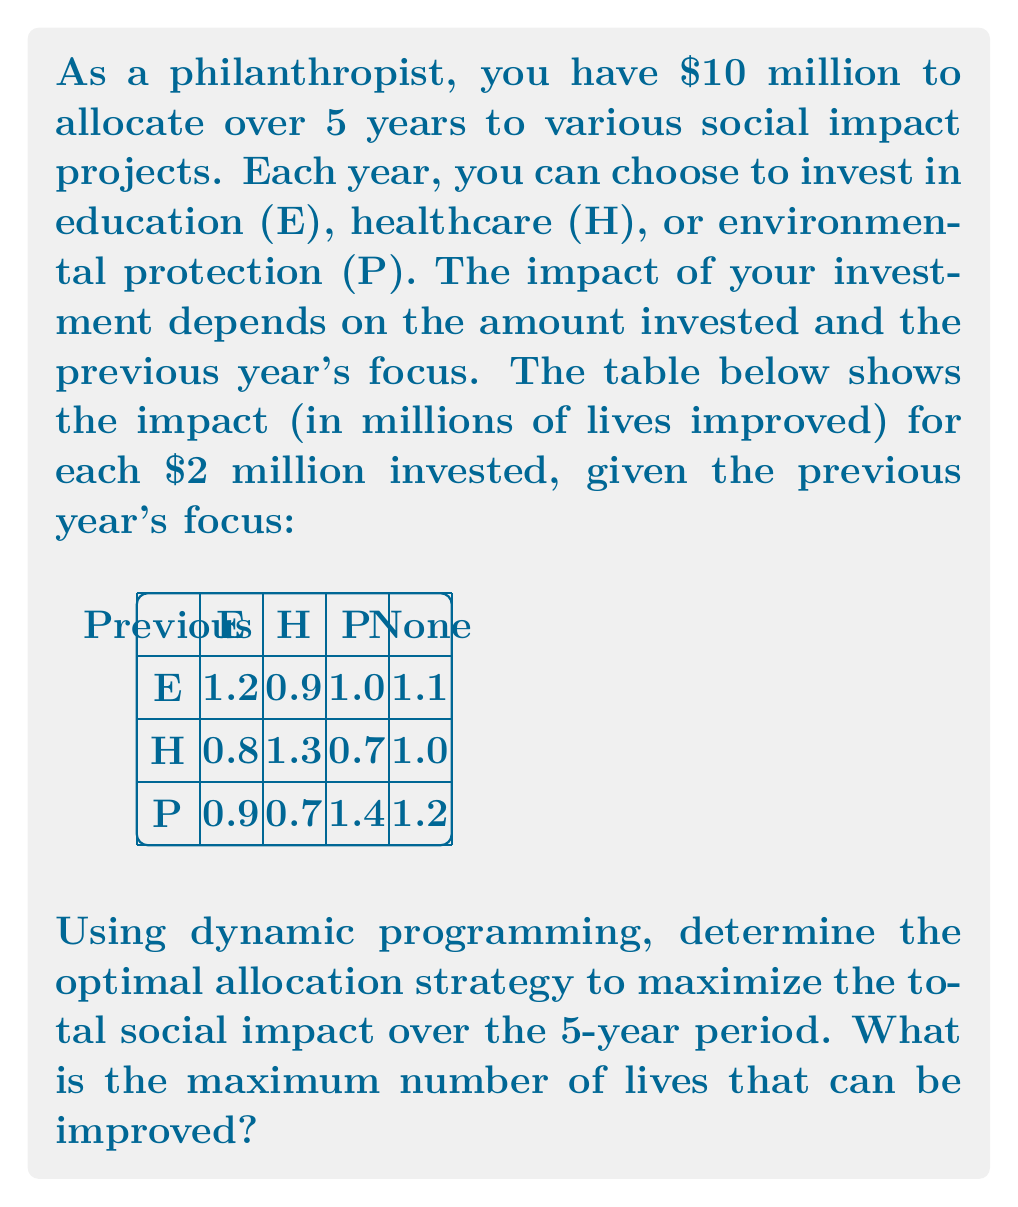Give your solution to this math problem. Let's solve this problem using dynamic programming:

1) Define the state: Let $dp[i][j]$ represent the maximum impact achievable in $i$ years with the last investment being $j$ (where $j$ can be E, H, P, or None for the initial state).

2) Define the recurrence relation:
   $$dp[i][j] = \max_{k \in \{E,H,P\}} \{dp[i-1][k] + impact[k][j]\}$$
   where $impact[k][j]$ is the impact of investing in $k$ given the previous investment was $j$.

3) Initialize the base case:
   $$dp[0][None] = 0$$
   $$dp[0][E] = dp[0][H] = dp[0][P] = -\infty$$

4) Fill the DP table:
   For $i$ from 1 to 5:
     For $j$ in $\{E, H, P\}$:
       $$dp[i][j] = \max_{k \in \{E,H,P,None\}} \{dp[i-1][k] + impact[j][k]\}$$

5) The final answer will be:
   $$\max_{j \in \{E,H,P\}} dp[5][j]$$

Let's fill the DP table:

| Year | E    | H    | P    |
|------|------|------|------|
| 0    | -inf | -inf | -inf |
| 1    | 1.1  | 1.0  | 1.2  |
| 2    | 2.3  | 2.4  | 2.6  |
| 3    | 3.7  | 3.7  | 4.0  |
| 4    | 5.1  | 5.0  | 5.4  |
| 5    | 6.5  | 6.4  | 6.8  |

The maximum impact is 6.8 million lives improved.

The optimal strategy is:
Year 1: P (1.2)
Year 2: P (1.4)
Year 3: P (1.4)
Year 4: P (1.4)
Year 5: P (1.4)
Answer: 6.8 million lives improved 